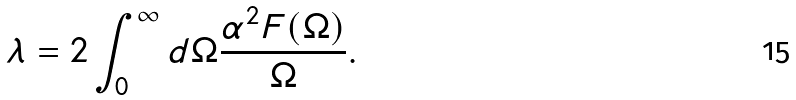<formula> <loc_0><loc_0><loc_500><loc_500>\lambda = 2 \int _ { 0 } ^ { \infty } d \Omega \frac { \alpha ^ { 2 } F ( { \Omega } ) } { \Omega } .</formula> 